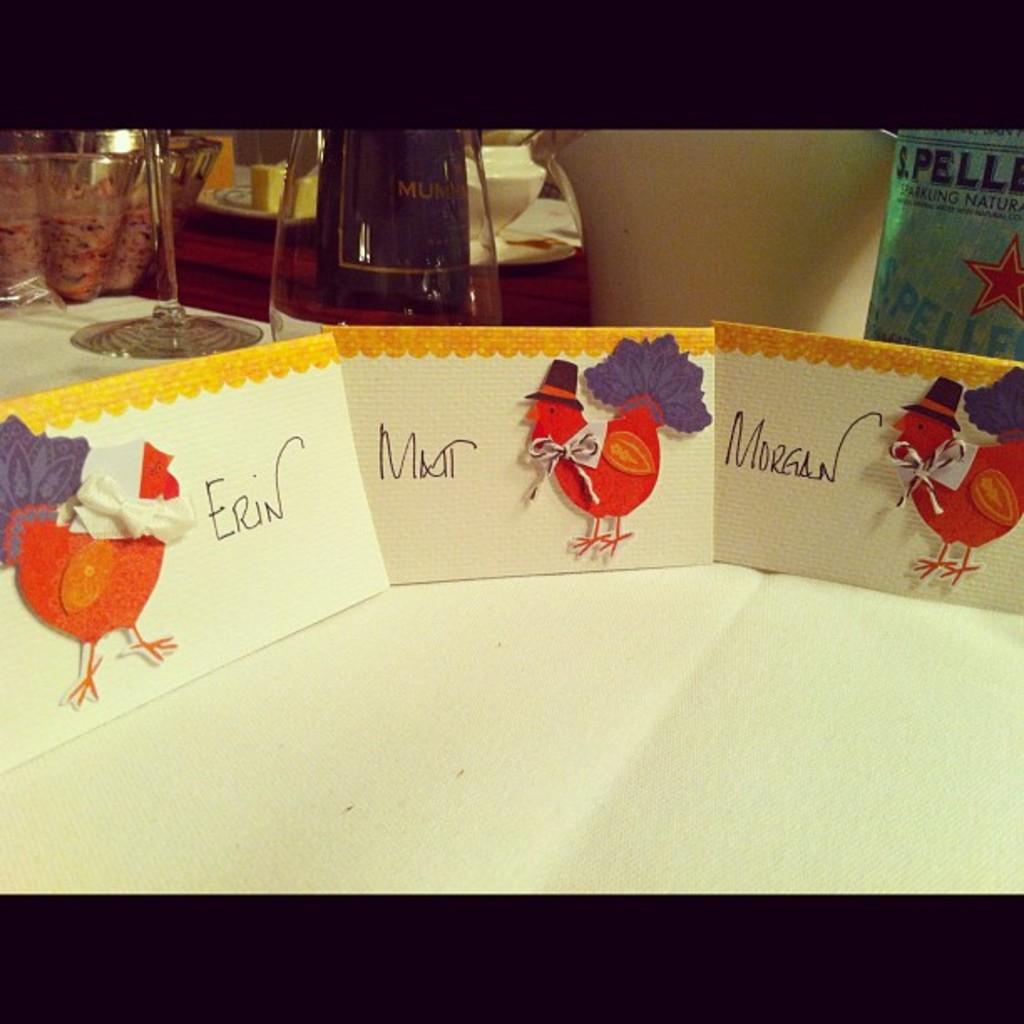Who is to the right of matt?
Ensure brevity in your answer.  Morgan. 